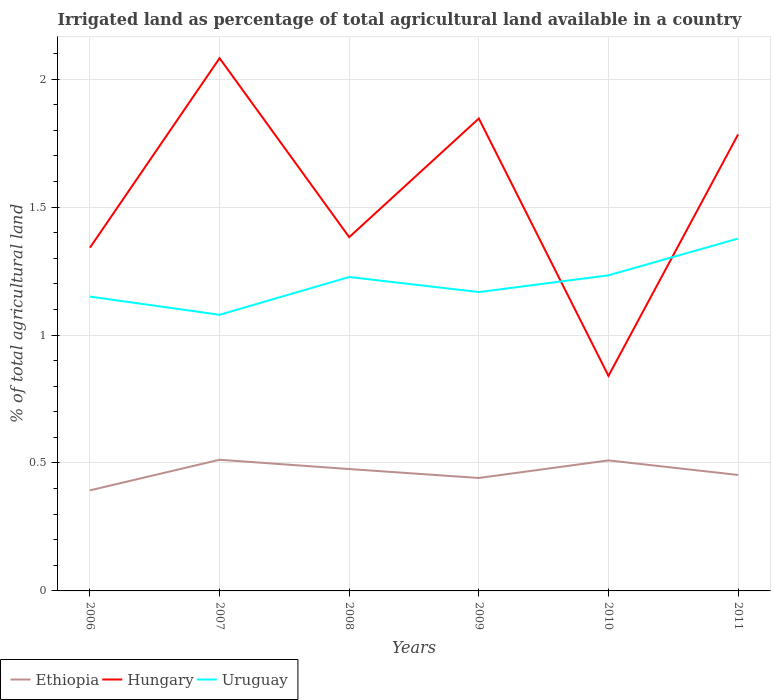How many different coloured lines are there?
Ensure brevity in your answer.  3. Does the line corresponding to Ethiopia intersect with the line corresponding to Uruguay?
Provide a short and direct response. No. Is the number of lines equal to the number of legend labels?
Your answer should be very brief. Yes. Across all years, what is the maximum percentage of irrigated land in Ethiopia?
Make the answer very short. 0.39. In which year was the percentage of irrigated land in Hungary maximum?
Offer a terse response. 2010. What is the total percentage of irrigated land in Uruguay in the graph?
Keep it short and to the point. -0.21. What is the difference between the highest and the second highest percentage of irrigated land in Ethiopia?
Offer a terse response. 0.12. How many lines are there?
Keep it short and to the point. 3. Does the graph contain any zero values?
Provide a short and direct response. No. How are the legend labels stacked?
Your response must be concise. Horizontal. What is the title of the graph?
Keep it short and to the point. Irrigated land as percentage of total agricultural land available in a country. What is the label or title of the Y-axis?
Your answer should be very brief. % of total agricultural land. What is the % of total agricultural land of Ethiopia in 2006?
Make the answer very short. 0.39. What is the % of total agricultural land of Hungary in 2006?
Offer a very short reply. 1.34. What is the % of total agricultural land of Uruguay in 2006?
Offer a terse response. 1.15. What is the % of total agricultural land of Ethiopia in 2007?
Your answer should be compact. 0.51. What is the % of total agricultural land in Hungary in 2007?
Ensure brevity in your answer.  2.08. What is the % of total agricultural land of Uruguay in 2007?
Offer a terse response. 1.08. What is the % of total agricultural land in Ethiopia in 2008?
Provide a short and direct response. 0.48. What is the % of total agricultural land of Hungary in 2008?
Your answer should be compact. 1.38. What is the % of total agricultural land in Uruguay in 2008?
Provide a succinct answer. 1.23. What is the % of total agricultural land in Ethiopia in 2009?
Provide a succinct answer. 0.44. What is the % of total agricultural land of Hungary in 2009?
Provide a short and direct response. 1.85. What is the % of total agricultural land in Uruguay in 2009?
Your response must be concise. 1.17. What is the % of total agricultural land of Ethiopia in 2010?
Give a very brief answer. 0.51. What is the % of total agricultural land in Hungary in 2010?
Offer a terse response. 0.84. What is the % of total agricultural land in Uruguay in 2010?
Give a very brief answer. 1.23. What is the % of total agricultural land in Ethiopia in 2011?
Your answer should be compact. 0.45. What is the % of total agricultural land in Hungary in 2011?
Your answer should be very brief. 1.78. What is the % of total agricultural land in Uruguay in 2011?
Make the answer very short. 1.38. Across all years, what is the maximum % of total agricultural land in Ethiopia?
Offer a very short reply. 0.51. Across all years, what is the maximum % of total agricultural land of Hungary?
Make the answer very short. 2.08. Across all years, what is the maximum % of total agricultural land of Uruguay?
Ensure brevity in your answer.  1.38. Across all years, what is the minimum % of total agricultural land in Ethiopia?
Keep it short and to the point. 0.39. Across all years, what is the minimum % of total agricultural land of Hungary?
Your answer should be very brief. 0.84. Across all years, what is the minimum % of total agricultural land in Uruguay?
Offer a terse response. 1.08. What is the total % of total agricultural land in Ethiopia in the graph?
Offer a very short reply. 2.79. What is the total % of total agricultural land of Hungary in the graph?
Give a very brief answer. 9.28. What is the total % of total agricultural land in Uruguay in the graph?
Give a very brief answer. 7.23. What is the difference between the % of total agricultural land of Ethiopia in 2006 and that in 2007?
Your answer should be compact. -0.12. What is the difference between the % of total agricultural land of Hungary in 2006 and that in 2007?
Your response must be concise. -0.74. What is the difference between the % of total agricultural land in Uruguay in 2006 and that in 2007?
Give a very brief answer. 0.07. What is the difference between the % of total agricultural land in Ethiopia in 2006 and that in 2008?
Keep it short and to the point. -0.08. What is the difference between the % of total agricultural land of Hungary in 2006 and that in 2008?
Your response must be concise. -0.04. What is the difference between the % of total agricultural land of Uruguay in 2006 and that in 2008?
Keep it short and to the point. -0.08. What is the difference between the % of total agricultural land of Ethiopia in 2006 and that in 2009?
Give a very brief answer. -0.05. What is the difference between the % of total agricultural land in Hungary in 2006 and that in 2009?
Keep it short and to the point. -0.5. What is the difference between the % of total agricultural land of Uruguay in 2006 and that in 2009?
Ensure brevity in your answer.  -0.02. What is the difference between the % of total agricultural land in Ethiopia in 2006 and that in 2010?
Offer a very short reply. -0.12. What is the difference between the % of total agricultural land in Hungary in 2006 and that in 2010?
Provide a succinct answer. 0.5. What is the difference between the % of total agricultural land in Uruguay in 2006 and that in 2010?
Make the answer very short. -0.08. What is the difference between the % of total agricultural land of Ethiopia in 2006 and that in 2011?
Your answer should be very brief. -0.06. What is the difference between the % of total agricultural land in Hungary in 2006 and that in 2011?
Ensure brevity in your answer.  -0.44. What is the difference between the % of total agricultural land in Uruguay in 2006 and that in 2011?
Offer a very short reply. -0.23. What is the difference between the % of total agricultural land of Ethiopia in 2007 and that in 2008?
Ensure brevity in your answer.  0.04. What is the difference between the % of total agricultural land in Hungary in 2007 and that in 2008?
Provide a short and direct response. 0.7. What is the difference between the % of total agricultural land of Uruguay in 2007 and that in 2008?
Ensure brevity in your answer.  -0.15. What is the difference between the % of total agricultural land of Ethiopia in 2007 and that in 2009?
Offer a terse response. 0.07. What is the difference between the % of total agricultural land of Hungary in 2007 and that in 2009?
Your answer should be compact. 0.24. What is the difference between the % of total agricultural land in Uruguay in 2007 and that in 2009?
Provide a short and direct response. -0.09. What is the difference between the % of total agricultural land of Ethiopia in 2007 and that in 2010?
Provide a short and direct response. 0. What is the difference between the % of total agricultural land of Hungary in 2007 and that in 2010?
Make the answer very short. 1.24. What is the difference between the % of total agricultural land of Uruguay in 2007 and that in 2010?
Give a very brief answer. -0.15. What is the difference between the % of total agricultural land in Ethiopia in 2007 and that in 2011?
Offer a terse response. 0.06. What is the difference between the % of total agricultural land in Hungary in 2007 and that in 2011?
Give a very brief answer. 0.3. What is the difference between the % of total agricultural land of Uruguay in 2007 and that in 2011?
Give a very brief answer. -0.3. What is the difference between the % of total agricultural land in Ethiopia in 2008 and that in 2009?
Make the answer very short. 0.03. What is the difference between the % of total agricultural land of Hungary in 2008 and that in 2009?
Ensure brevity in your answer.  -0.46. What is the difference between the % of total agricultural land in Uruguay in 2008 and that in 2009?
Your answer should be compact. 0.06. What is the difference between the % of total agricultural land in Ethiopia in 2008 and that in 2010?
Your answer should be compact. -0.03. What is the difference between the % of total agricultural land in Hungary in 2008 and that in 2010?
Make the answer very short. 0.54. What is the difference between the % of total agricultural land of Uruguay in 2008 and that in 2010?
Provide a succinct answer. -0.01. What is the difference between the % of total agricultural land of Ethiopia in 2008 and that in 2011?
Offer a very short reply. 0.02. What is the difference between the % of total agricultural land of Hungary in 2008 and that in 2011?
Your response must be concise. -0.4. What is the difference between the % of total agricultural land of Uruguay in 2008 and that in 2011?
Provide a short and direct response. -0.15. What is the difference between the % of total agricultural land of Ethiopia in 2009 and that in 2010?
Give a very brief answer. -0.07. What is the difference between the % of total agricultural land in Uruguay in 2009 and that in 2010?
Offer a very short reply. -0.07. What is the difference between the % of total agricultural land of Ethiopia in 2009 and that in 2011?
Keep it short and to the point. -0.01. What is the difference between the % of total agricultural land of Hungary in 2009 and that in 2011?
Provide a succinct answer. 0.06. What is the difference between the % of total agricultural land of Uruguay in 2009 and that in 2011?
Offer a terse response. -0.21. What is the difference between the % of total agricultural land in Ethiopia in 2010 and that in 2011?
Your response must be concise. 0.06. What is the difference between the % of total agricultural land of Hungary in 2010 and that in 2011?
Your response must be concise. -0.94. What is the difference between the % of total agricultural land of Uruguay in 2010 and that in 2011?
Keep it short and to the point. -0.14. What is the difference between the % of total agricultural land of Ethiopia in 2006 and the % of total agricultural land of Hungary in 2007?
Offer a very short reply. -1.69. What is the difference between the % of total agricultural land in Ethiopia in 2006 and the % of total agricultural land in Uruguay in 2007?
Provide a short and direct response. -0.69. What is the difference between the % of total agricultural land of Hungary in 2006 and the % of total agricultural land of Uruguay in 2007?
Your response must be concise. 0.26. What is the difference between the % of total agricultural land in Ethiopia in 2006 and the % of total agricultural land in Hungary in 2008?
Provide a succinct answer. -0.99. What is the difference between the % of total agricultural land in Ethiopia in 2006 and the % of total agricultural land in Uruguay in 2008?
Your answer should be very brief. -0.83. What is the difference between the % of total agricultural land in Hungary in 2006 and the % of total agricultural land in Uruguay in 2008?
Ensure brevity in your answer.  0.11. What is the difference between the % of total agricultural land in Ethiopia in 2006 and the % of total agricultural land in Hungary in 2009?
Provide a short and direct response. -1.45. What is the difference between the % of total agricultural land of Ethiopia in 2006 and the % of total agricultural land of Uruguay in 2009?
Your answer should be compact. -0.77. What is the difference between the % of total agricultural land of Hungary in 2006 and the % of total agricultural land of Uruguay in 2009?
Make the answer very short. 0.17. What is the difference between the % of total agricultural land in Ethiopia in 2006 and the % of total agricultural land in Hungary in 2010?
Make the answer very short. -0.45. What is the difference between the % of total agricultural land in Ethiopia in 2006 and the % of total agricultural land in Uruguay in 2010?
Ensure brevity in your answer.  -0.84. What is the difference between the % of total agricultural land in Hungary in 2006 and the % of total agricultural land in Uruguay in 2010?
Your response must be concise. 0.11. What is the difference between the % of total agricultural land of Ethiopia in 2006 and the % of total agricultural land of Hungary in 2011?
Provide a short and direct response. -1.39. What is the difference between the % of total agricultural land of Ethiopia in 2006 and the % of total agricultural land of Uruguay in 2011?
Your answer should be very brief. -0.98. What is the difference between the % of total agricultural land of Hungary in 2006 and the % of total agricultural land of Uruguay in 2011?
Provide a succinct answer. -0.04. What is the difference between the % of total agricultural land in Ethiopia in 2007 and the % of total agricultural land in Hungary in 2008?
Provide a succinct answer. -0.87. What is the difference between the % of total agricultural land in Ethiopia in 2007 and the % of total agricultural land in Uruguay in 2008?
Your answer should be compact. -0.71. What is the difference between the % of total agricultural land of Hungary in 2007 and the % of total agricultural land of Uruguay in 2008?
Ensure brevity in your answer.  0.86. What is the difference between the % of total agricultural land of Ethiopia in 2007 and the % of total agricultural land of Hungary in 2009?
Provide a short and direct response. -1.33. What is the difference between the % of total agricultural land of Ethiopia in 2007 and the % of total agricultural land of Uruguay in 2009?
Provide a succinct answer. -0.66. What is the difference between the % of total agricultural land in Hungary in 2007 and the % of total agricultural land in Uruguay in 2009?
Provide a short and direct response. 0.91. What is the difference between the % of total agricultural land in Ethiopia in 2007 and the % of total agricultural land in Hungary in 2010?
Your answer should be compact. -0.33. What is the difference between the % of total agricultural land in Ethiopia in 2007 and the % of total agricultural land in Uruguay in 2010?
Ensure brevity in your answer.  -0.72. What is the difference between the % of total agricultural land of Hungary in 2007 and the % of total agricultural land of Uruguay in 2010?
Give a very brief answer. 0.85. What is the difference between the % of total agricultural land in Ethiopia in 2007 and the % of total agricultural land in Hungary in 2011?
Provide a succinct answer. -1.27. What is the difference between the % of total agricultural land of Ethiopia in 2007 and the % of total agricultural land of Uruguay in 2011?
Make the answer very short. -0.86. What is the difference between the % of total agricultural land of Hungary in 2007 and the % of total agricultural land of Uruguay in 2011?
Give a very brief answer. 0.7. What is the difference between the % of total agricultural land in Ethiopia in 2008 and the % of total agricultural land in Hungary in 2009?
Keep it short and to the point. -1.37. What is the difference between the % of total agricultural land of Ethiopia in 2008 and the % of total agricultural land of Uruguay in 2009?
Your answer should be very brief. -0.69. What is the difference between the % of total agricultural land in Hungary in 2008 and the % of total agricultural land in Uruguay in 2009?
Make the answer very short. 0.21. What is the difference between the % of total agricultural land of Ethiopia in 2008 and the % of total agricultural land of Hungary in 2010?
Give a very brief answer. -0.36. What is the difference between the % of total agricultural land in Ethiopia in 2008 and the % of total agricultural land in Uruguay in 2010?
Make the answer very short. -0.76. What is the difference between the % of total agricultural land in Hungary in 2008 and the % of total agricultural land in Uruguay in 2010?
Your answer should be compact. 0.15. What is the difference between the % of total agricultural land in Ethiopia in 2008 and the % of total agricultural land in Hungary in 2011?
Provide a succinct answer. -1.31. What is the difference between the % of total agricultural land of Ethiopia in 2008 and the % of total agricultural land of Uruguay in 2011?
Provide a short and direct response. -0.9. What is the difference between the % of total agricultural land in Hungary in 2008 and the % of total agricultural land in Uruguay in 2011?
Keep it short and to the point. 0.01. What is the difference between the % of total agricultural land of Ethiopia in 2009 and the % of total agricultural land of Hungary in 2010?
Your answer should be very brief. -0.4. What is the difference between the % of total agricultural land of Ethiopia in 2009 and the % of total agricultural land of Uruguay in 2010?
Your response must be concise. -0.79. What is the difference between the % of total agricultural land of Hungary in 2009 and the % of total agricultural land of Uruguay in 2010?
Give a very brief answer. 0.61. What is the difference between the % of total agricultural land in Ethiopia in 2009 and the % of total agricultural land in Hungary in 2011?
Provide a succinct answer. -1.34. What is the difference between the % of total agricultural land in Ethiopia in 2009 and the % of total agricultural land in Uruguay in 2011?
Offer a terse response. -0.94. What is the difference between the % of total agricultural land of Hungary in 2009 and the % of total agricultural land of Uruguay in 2011?
Your response must be concise. 0.47. What is the difference between the % of total agricultural land of Ethiopia in 2010 and the % of total agricultural land of Hungary in 2011?
Your response must be concise. -1.27. What is the difference between the % of total agricultural land in Ethiopia in 2010 and the % of total agricultural land in Uruguay in 2011?
Offer a terse response. -0.87. What is the difference between the % of total agricultural land of Hungary in 2010 and the % of total agricultural land of Uruguay in 2011?
Keep it short and to the point. -0.54. What is the average % of total agricultural land in Ethiopia per year?
Give a very brief answer. 0.46. What is the average % of total agricultural land in Hungary per year?
Keep it short and to the point. 1.55. What is the average % of total agricultural land in Uruguay per year?
Make the answer very short. 1.21. In the year 2006, what is the difference between the % of total agricultural land in Ethiopia and % of total agricultural land in Hungary?
Give a very brief answer. -0.95. In the year 2006, what is the difference between the % of total agricultural land of Ethiopia and % of total agricultural land of Uruguay?
Offer a very short reply. -0.76. In the year 2006, what is the difference between the % of total agricultural land of Hungary and % of total agricultural land of Uruguay?
Your answer should be compact. 0.19. In the year 2007, what is the difference between the % of total agricultural land in Ethiopia and % of total agricultural land in Hungary?
Give a very brief answer. -1.57. In the year 2007, what is the difference between the % of total agricultural land of Ethiopia and % of total agricultural land of Uruguay?
Keep it short and to the point. -0.57. In the year 2007, what is the difference between the % of total agricultural land of Hungary and % of total agricultural land of Uruguay?
Your answer should be very brief. 1. In the year 2008, what is the difference between the % of total agricultural land of Ethiopia and % of total agricultural land of Hungary?
Your answer should be very brief. -0.91. In the year 2008, what is the difference between the % of total agricultural land of Ethiopia and % of total agricultural land of Uruguay?
Offer a terse response. -0.75. In the year 2008, what is the difference between the % of total agricultural land of Hungary and % of total agricultural land of Uruguay?
Your answer should be compact. 0.16. In the year 2009, what is the difference between the % of total agricultural land in Ethiopia and % of total agricultural land in Hungary?
Ensure brevity in your answer.  -1.4. In the year 2009, what is the difference between the % of total agricultural land of Ethiopia and % of total agricultural land of Uruguay?
Your answer should be very brief. -0.73. In the year 2009, what is the difference between the % of total agricultural land in Hungary and % of total agricultural land in Uruguay?
Offer a very short reply. 0.68. In the year 2010, what is the difference between the % of total agricultural land of Ethiopia and % of total agricultural land of Hungary?
Ensure brevity in your answer.  -0.33. In the year 2010, what is the difference between the % of total agricultural land in Ethiopia and % of total agricultural land in Uruguay?
Your answer should be very brief. -0.72. In the year 2010, what is the difference between the % of total agricultural land in Hungary and % of total agricultural land in Uruguay?
Keep it short and to the point. -0.39. In the year 2011, what is the difference between the % of total agricultural land of Ethiopia and % of total agricultural land of Hungary?
Offer a very short reply. -1.33. In the year 2011, what is the difference between the % of total agricultural land in Ethiopia and % of total agricultural land in Uruguay?
Keep it short and to the point. -0.92. In the year 2011, what is the difference between the % of total agricultural land of Hungary and % of total agricultural land of Uruguay?
Keep it short and to the point. 0.41. What is the ratio of the % of total agricultural land in Ethiopia in 2006 to that in 2007?
Your response must be concise. 0.77. What is the ratio of the % of total agricultural land of Hungary in 2006 to that in 2007?
Your answer should be very brief. 0.64. What is the ratio of the % of total agricultural land of Uruguay in 2006 to that in 2007?
Give a very brief answer. 1.07. What is the ratio of the % of total agricultural land in Ethiopia in 2006 to that in 2008?
Your answer should be very brief. 0.83. What is the ratio of the % of total agricultural land in Hungary in 2006 to that in 2008?
Provide a succinct answer. 0.97. What is the ratio of the % of total agricultural land in Ethiopia in 2006 to that in 2009?
Keep it short and to the point. 0.89. What is the ratio of the % of total agricultural land of Hungary in 2006 to that in 2009?
Give a very brief answer. 0.73. What is the ratio of the % of total agricultural land of Uruguay in 2006 to that in 2009?
Make the answer very short. 0.98. What is the ratio of the % of total agricultural land in Ethiopia in 2006 to that in 2010?
Ensure brevity in your answer.  0.77. What is the ratio of the % of total agricultural land in Hungary in 2006 to that in 2010?
Ensure brevity in your answer.  1.6. What is the ratio of the % of total agricultural land of Uruguay in 2006 to that in 2010?
Make the answer very short. 0.93. What is the ratio of the % of total agricultural land in Ethiopia in 2006 to that in 2011?
Offer a very short reply. 0.87. What is the ratio of the % of total agricultural land in Hungary in 2006 to that in 2011?
Keep it short and to the point. 0.75. What is the ratio of the % of total agricultural land in Uruguay in 2006 to that in 2011?
Ensure brevity in your answer.  0.84. What is the ratio of the % of total agricultural land of Ethiopia in 2007 to that in 2008?
Provide a short and direct response. 1.08. What is the ratio of the % of total agricultural land in Hungary in 2007 to that in 2008?
Your answer should be compact. 1.51. What is the ratio of the % of total agricultural land in Uruguay in 2007 to that in 2008?
Keep it short and to the point. 0.88. What is the ratio of the % of total agricultural land of Ethiopia in 2007 to that in 2009?
Make the answer very short. 1.16. What is the ratio of the % of total agricultural land of Hungary in 2007 to that in 2009?
Your answer should be very brief. 1.13. What is the ratio of the % of total agricultural land of Uruguay in 2007 to that in 2009?
Provide a succinct answer. 0.92. What is the ratio of the % of total agricultural land in Hungary in 2007 to that in 2010?
Your answer should be compact. 2.48. What is the ratio of the % of total agricultural land in Uruguay in 2007 to that in 2010?
Ensure brevity in your answer.  0.87. What is the ratio of the % of total agricultural land in Ethiopia in 2007 to that in 2011?
Your response must be concise. 1.13. What is the ratio of the % of total agricultural land in Hungary in 2007 to that in 2011?
Offer a terse response. 1.17. What is the ratio of the % of total agricultural land in Uruguay in 2007 to that in 2011?
Offer a terse response. 0.78. What is the ratio of the % of total agricultural land in Ethiopia in 2008 to that in 2009?
Your answer should be compact. 1.08. What is the ratio of the % of total agricultural land in Hungary in 2008 to that in 2009?
Make the answer very short. 0.75. What is the ratio of the % of total agricultural land of Uruguay in 2008 to that in 2009?
Offer a terse response. 1.05. What is the ratio of the % of total agricultural land in Ethiopia in 2008 to that in 2010?
Offer a terse response. 0.93. What is the ratio of the % of total agricultural land of Hungary in 2008 to that in 2010?
Offer a very short reply. 1.65. What is the ratio of the % of total agricultural land in Ethiopia in 2008 to that in 2011?
Keep it short and to the point. 1.05. What is the ratio of the % of total agricultural land of Hungary in 2008 to that in 2011?
Keep it short and to the point. 0.78. What is the ratio of the % of total agricultural land of Uruguay in 2008 to that in 2011?
Keep it short and to the point. 0.89. What is the ratio of the % of total agricultural land of Ethiopia in 2009 to that in 2010?
Your response must be concise. 0.87. What is the ratio of the % of total agricultural land of Hungary in 2009 to that in 2010?
Offer a terse response. 2.2. What is the ratio of the % of total agricultural land in Uruguay in 2009 to that in 2010?
Your answer should be compact. 0.95. What is the ratio of the % of total agricultural land of Ethiopia in 2009 to that in 2011?
Make the answer very short. 0.97. What is the ratio of the % of total agricultural land of Hungary in 2009 to that in 2011?
Offer a very short reply. 1.03. What is the ratio of the % of total agricultural land of Uruguay in 2009 to that in 2011?
Give a very brief answer. 0.85. What is the ratio of the % of total agricultural land in Ethiopia in 2010 to that in 2011?
Give a very brief answer. 1.13. What is the ratio of the % of total agricultural land of Hungary in 2010 to that in 2011?
Ensure brevity in your answer.  0.47. What is the ratio of the % of total agricultural land of Uruguay in 2010 to that in 2011?
Make the answer very short. 0.9. What is the difference between the highest and the second highest % of total agricultural land in Ethiopia?
Offer a terse response. 0. What is the difference between the highest and the second highest % of total agricultural land of Hungary?
Keep it short and to the point. 0.24. What is the difference between the highest and the second highest % of total agricultural land of Uruguay?
Your response must be concise. 0.14. What is the difference between the highest and the lowest % of total agricultural land of Ethiopia?
Give a very brief answer. 0.12. What is the difference between the highest and the lowest % of total agricultural land of Hungary?
Offer a terse response. 1.24. What is the difference between the highest and the lowest % of total agricultural land in Uruguay?
Your response must be concise. 0.3. 